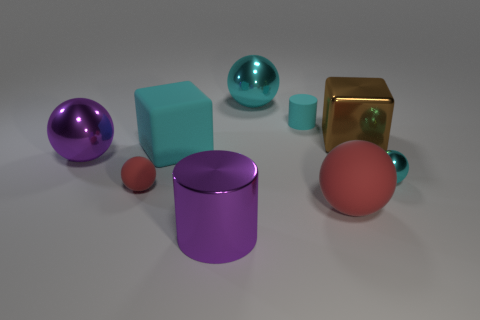Subtract all cyan spheres. How many were subtracted if there are1cyan spheres left? 1 Subtract all cyan cylinders. How many red spheres are left? 2 Subtract all cyan spheres. How many spheres are left? 3 Subtract all tiny matte balls. How many balls are left? 4 Add 1 large red matte objects. How many objects exist? 10 Subtract all blue spheres. Subtract all purple cylinders. How many spheres are left? 5 Subtract all spheres. How many objects are left? 4 Add 8 cyan matte cylinders. How many cyan matte cylinders exist? 9 Subtract 1 cyan blocks. How many objects are left? 8 Subtract all small brown things. Subtract all big cyan balls. How many objects are left? 8 